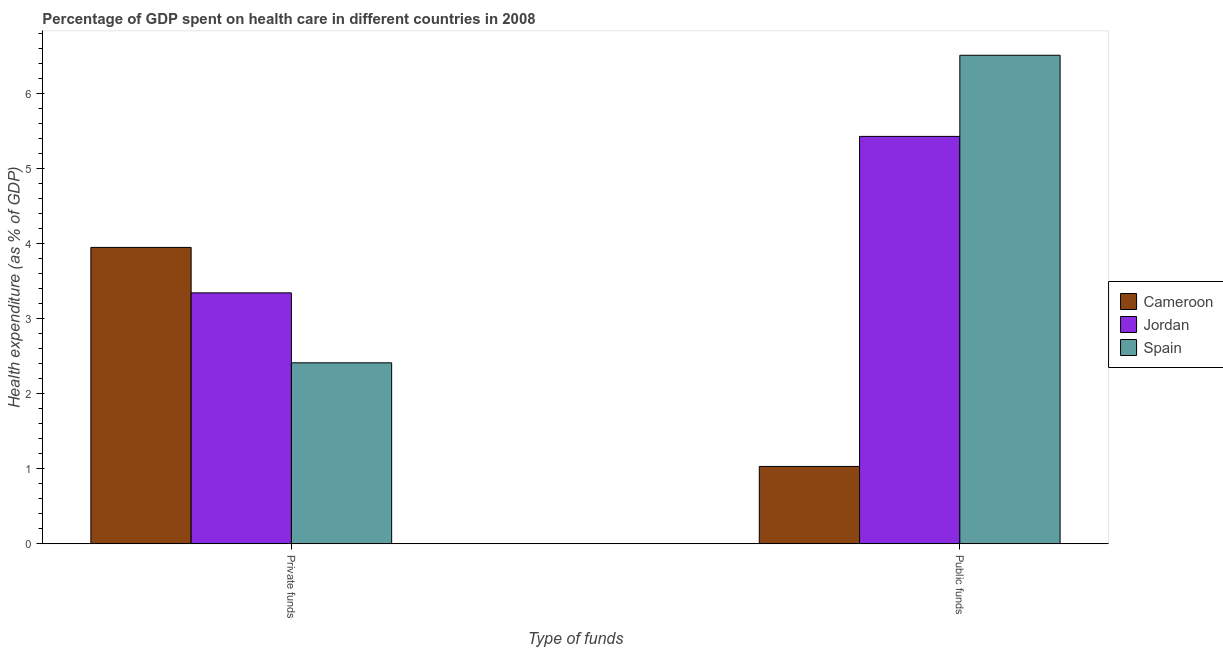How many groups of bars are there?
Provide a succinct answer. 2. Are the number of bars per tick equal to the number of legend labels?
Offer a very short reply. Yes. Are the number of bars on each tick of the X-axis equal?
Offer a terse response. Yes. How many bars are there on the 1st tick from the right?
Offer a very short reply. 3. What is the label of the 2nd group of bars from the left?
Provide a succinct answer. Public funds. What is the amount of public funds spent in healthcare in Cameroon?
Keep it short and to the point. 1.03. Across all countries, what is the maximum amount of public funds spent in healthcare?
Provide a short and direct response. 6.51. Across all countries, what is the minimum amount of private funds spent in healthcare?
Provide a short and direct response. 2.41. In which country was the amount of private funds spent in healthcare maximum?
Keep it short and to the point. Cameroon. In which country was the amount of public funds spent in healthcare minimum?
Provide a succinct answer. Cameroon. What is the total amount of private funds spent in healthcare in the graph?
Give a very brief answer. 9.71. What is the difference between the amount of public funds spent in healthcare in Cameroon and that in Spain?
Provide a short and direct response. -5.48. What is the difference between the amount of private funds spent in healthcare in Spain and the amount of public funds spent in healthcare in Jordan?
Provide a succinct answer. -3.02. What is the average amount of private funds spent in healthcare per country?
Offer a terse response. 3.24. What is the difference between the amount of private funds spent in healthcare and amount of public funds spent in healthcare in Cameroon?
Keep it short and to the point. 2.92. In how many countries, is the amount of private funds spent in healthcare greater than 6.4 %?
Make the answer very short. 0. What is the ratio of the amount of private funds spent in healthcare in Jordan to that in Cameroon?
Offer a terse response. 0.85. Is the amount of private funds spent in healthcare in Jordan less than that in Spain?
Make the answer very short. No. What does the 1st bar from the left in Public funds represents?
Offer a very short reply. Cameroon. What does the 2nd bar from the right in Public funds represents?
Your answer should be compact. Jordan. How many bars are there?
Make the answer very short. 6. Are all the bars in the graph horizontal?
Your answer should be compact. No. What is the difference between two consecutive major ticks on the Y-axis?
Provide a short and direct response. 1. Does the graph contain any zero values?
Offer a very short reply. No. Where does the legend appear in the graph?
Ensure brevity in your answer.  Center right. What is the title of the graph?
Provide a short and direct response. Percentage of GDP spent on health care in different countries in 2008. Does "Isle of Man" appear as one of the legend labels in the graph?
Make the answer very short. No. What is the label or title of the X-axis?
Your answer should be very brief. Type of funds. What is the label or title of the Y-axis?
Your answer should be very brief. Health expenditure (as % of GDP). What is the Health expenditure (as % of GDP) in Cameroon in Private funds?
Ensure brevity in your answer.  3.95. What is the Health expenditure (as % of GDP) of Jordan in Private funds?
Keep it short and to the point. 3.35. What is the Health expenditure (as % of GDP) of Spain in Private funds?
Your response must be concise. 2.41. What is the Health expenditure (as % of GDP) in Cameroon in Public funds?
Offer a terse response. 1.03. What is the Health expenditure (as % of GDP) of Jordan in Public funds?
Your answer should be compact. 5.43. What is the Health expenditure (as % of GDP) in Spain in Public funds?
Give a very brief answer. 6.51. Across all Type of funds, what is the maximum Health expenditure (as % of GDP) of Cameroon?
Ensure brevity in your answer.  3.95. Across all Type of funds, what is the maximum Health expenditure (as % of GDP) of Jordan?
Offer a terse response. 5.43. Across all Type of funds, what is the maximum Health expenditure (as % of GDP) of Spain?
Your answer should be compact. 6.51. Across all Type of funds, what is the minimum Health expenditure (as % of GDP) of Cameroon?
Keep it short and to the point. 1.03. Across all Type of funds, what is the minimum Health expenditure (as % of GDP) of Jordan?
Keep it short and to the point. 3.35. Across all Type of funds, what is the minimum Health expenditure (as % of GDP) in Spain?
Your answer should be very brief. 2.41. What is the total Health expenditure (as % of GDP) in Cameroon in the graph?
Make the answer very short. 4.98. What is the total Health expenditure (as % of GDP) in Jordan in the graph?
Keep it short and to the point. 8.78. What is the total Health expenditure (as % of GDP) of Spain in the graph?
Give a very brief answer. 8.93. What is the difference between the Health expenditure (as % of GDP) of Cameroon in Private funds and that in Public funds?
Offer a very short reply. 2.92. What is the difference between the Health expenditure (as % of GDP) in Jordan in Private funds and that in Public funds?
Offer a very short reply. -2.09. What is the difference between the Health expenditure (as % of GDP) in Spain in Private funds and that in Public funds?
Your answer should be compact. -4.1. What is the difference between the Health expenditure (as % of GDP) of Cameroon in Private funds and the Health expenditure (as % of GDP) of Jordan in Public funds?
Offer a very short reply. -1.48. What is the difference between the Health expenditure (as % of GDP) in Cameroon in Private funds and the Health expenditure (as % of GDP) in Spain in Public funds?
Your answer should be very brief. -2.56. What is the difference between the Health expenditure (as % of GDP) in Jordan in Private funds and the Health expenditure (as % of GDP) in Spain in Public funds?
Your answer should be very brief. -3.17. What is the average Health expenditure (as % of GDP) in Cameroon per Type of funds?
Make the answer very short. 2.49. What is the average Health expenditure (as % of GDP) in Jordan per Type of funds?
Give a very brief answer. 4.39. What is the average Health expenditure (as % of GDP) in Spain per Type of funds?
Keep it short and to the point. 4.46. What is the difference between the Health expenditure (as % of GDP) of Cameroon and Health expenditure (as % of GDP) of Jordan in Private funds?
Provide a succinct answer. 0.61. What is the difference between the Health expenditure (as % of GDP) in Cameroon and Health expenditure (as % of GDP) in Spain in Private funds?
Make the answer very short. 1.54. What is the difference between the Health expenditure (as % of GDP) of Jordan and Health expenditure (as % of GDP) of Spain in Private funds?
Provide a short and direct response. 0.93. What is the difference between the Health expenditure (as % of GDP) in Cameroon and Health expenditure (as % of GDP) in Jordan in Public funds?
Offer a terse response. -4.4. What is the difference between the Health expenditure (as % of GDP) in Cameroon and Health expenditure (as % of GDP) in Spain in Public funds?
Make the answer very short. -5.48. What is the difference between the Health expenditure (as % of GDP) in Jordan and Health expenditure (as % of GDP) in Spain in Public funds?
Your answer should be compact. -1.08. What is the ratio of the Health expenditure (as % of GDP) in Cameroon in Private funds to that in Public funds?
Offer a very short reply. 3.83. What is the ratio of the Health expenditure (as % of GDP) in Jordan in Private funds to that in Public funds?
Give a very brief answer. 0.62. What is the ratio of the Health expenditure (as % of GDP) in Spain in Private funds to that in Public funds?
Provide a succinct answer. 0.37. What is the difference between the highest and the second highest Health expenditure (as % of GDP) of Cameroon?
Give a very brief answer. 2.92. What is the difference between the highest and the second highest Health expenditure (as % of GDP) in Jordan?
Provide a short and direct response. 2.09. What is the difference between the highest and the second highest Health expenditure (as % of GDP) in Spain?
Your answer should be very brief. 4.1. What is the difference between the highest and the lowest Health expenditure (as % of GDP) of Cameroon?
Offer a very short reply. 2.92. What is the difference between the highest and the lowest Health expenditure (as % of GDP) in Jordan?
Your answer should be compact. 2.09. What is the difference between the highest and the lowest Health expenditure (as % of GDP) in Spain?
Your answer should be compact. 4.1. 